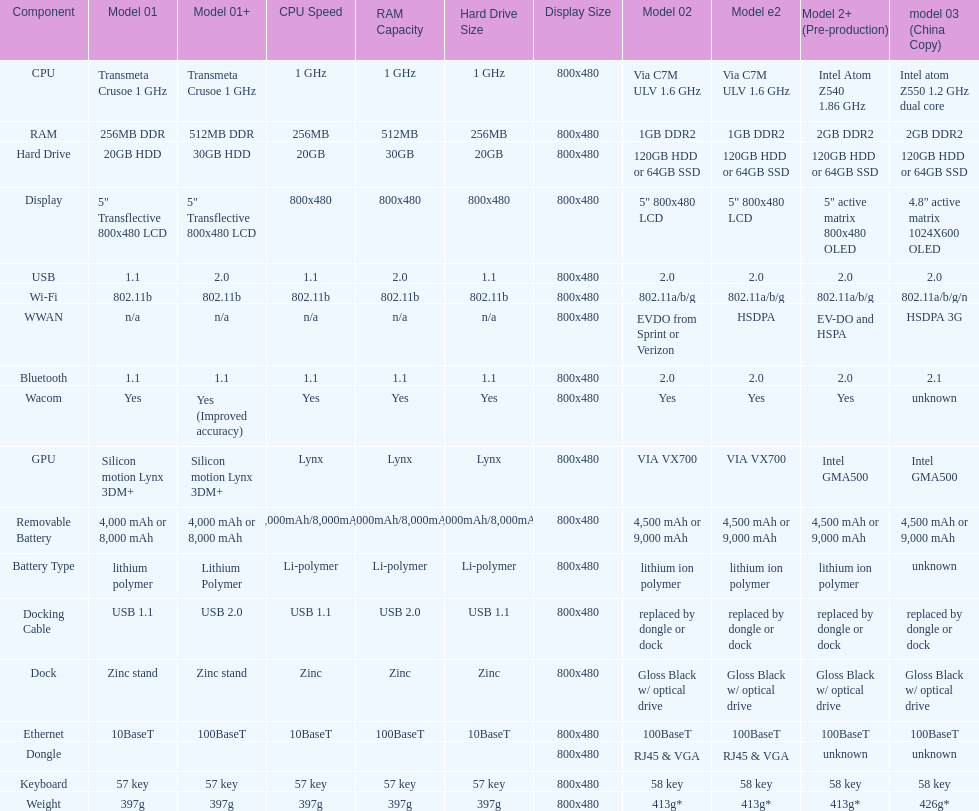What is the average number of models that have usb 2.0? 5. Would you mind parsing the complete table? {'header': ['Component', 'Model 01', 'Model 01+', 'CPU Speed', 'RAM Capacity', 'Hard Drive Size', 'Display Size', 'Model 02', 'Model e2', 'Model 2+ (Pre-production)', 'model 03 (China Copy)'], 'rows': [['CPU', 'Transmeta Crusoe 1\xa0GHz', 'Transmeta Crusoe 1\xa0GHz', '1 GHz', '1 GHz', '1 GHz', '800x480', 'Via C7M ULV 1.6\xa0GHz', 'Via C7M ULV 1.6\xa0GHz', 'Intel Atom Z540 1.86\xa0GHz', 'Intel atom Z550 1.2\xa0GHz dual core'], ['RAM', '256MB DDR', '512MB DDR', '256MB', '512MB', '256MB', '800x480', '1GB DDR2', '1GB DDR2', '2GB DDR2', '2GB DDR2'], ['Hard Drive', '20GB HDD', '30GB HDD', '20GB', '30GB', '20GB', '800x480', '120GB HDD or 64GB SSD', '120GB HDD or 64GB SSD', '120GB HDD or 64GB SSD', '120GB HDD or 64GB SSD'], ['Display', '5" Transflective 800x480 LCD', '5" Transflective 800x480 LCD', '800x480', '800x480', '800x480', '800x480', '5" 800x480 LCD', '5" 800x480 LCD', '5" active matrix 800x480 OLED', '4.8" active matrix 1024X600 OLED'], ['USB', '1.1', '2.0', '1.1', '2.0', '1.1', '800x480', '2.0', '2.0', '2.0', '2.0'], ['Wi-Fi', '802.11b', '802.11b', '802.11b', '802.11b', '802.11b', '800x480', '802.11a/b/g', '802.11a/b/g', '802.11a/b/g', '802.11a/b/g/n'], ['WWAN', 'n/a', 'n/a', 'n/a', 'n/a', 'n/a', '800x480', 'EVDO from Sprint or Verizon', 'HSDPA', 'EV-DO and HSPA', 'HSDPA 3G'], ['Bluetooth', '1.1', '1.1', '1.1', '1.1', '1.1', '800x480', '2.0', '2.0', '2.0', '2.1'], ['Wacom', 'Yes', 'Yes (Improved accuracy)', 'Yes', 'Yes', 'Yes', '800x480', 'Yes', 'Yes', 'Yes', 'unknown'], ['GPU', 'Silicon motion Lynx 3DM+', 'Silicon motion Lynx 3DM+', 'Lynx', 'Lynx', 'Lynx', '800x480', 'VIA VX700', 'VIA VX700', 'Intel GMA500', 'Intel GMA500'], ['Removable Battery', '4,000 mAh or 8,000 mAh', '4,000 mAh or 8,000 mAh', '4,000mAh/8,000mAh', '4,000mAh/8,000mAh', '4,000mAh/8,000mAh', '800x480', '4,500 mAh or 9,000 mAh', '4,500 mAh or 9,000 mAh', '4,500 mAh or 9,000 mAh', '4,500 mAh or 9,000 mAh'], ['Battery Type', 'lithium polymer', 'Lithium Polymer', 'Li-polymer', 'Li-polymer', 'Li-polymer', '800x480', 'lithium ion polymer', 'lithium ion polymer', 'lithium ion polymer', 'unknown'], ['Docking Cable', 'USB 1.1', 'USB 2.0', 'USB 1.1', 'USB 2.0', 'USB 1.1', '800x480', 'replaced by dongle or dock', 'replaced by dongle or dock', 'replaced by dongle or dock', 'replaced by dongle or dock'], ['Dock', 'Zinc stand', 'Zinc stand', 'Zinc', 'Zinc', 'Zinc', '800x480', 'Gloss Black w/ optical drive', 'Gloss Black w/ optical drive', 'Gloss Black w/ optical drive', 'Gloss Black w/ optical drive'], ['Ethernet', '10BaseT', '100BaseT', '10BaseT', '100BaseT', '10BaseT', '800x480', '100BaseT', '100BaseT', '100BaseT', '100BaseT'], ['Dongle', '', '', '', '', '', '800x480', 'RJ45 & VGA', 'RJ45 & VGA', 'unknown', 'unknown'], ['Keyboard', '57 key', '57 key', '57 key', '57 key', '57 key', '800x480', '58 key', '58 key', '58 key', '58 key'], ['Weight', '397g', '397g', '397g', '397g', '397g', '800x480', '413g*', '413g*', '413g*', '426g*']]} 